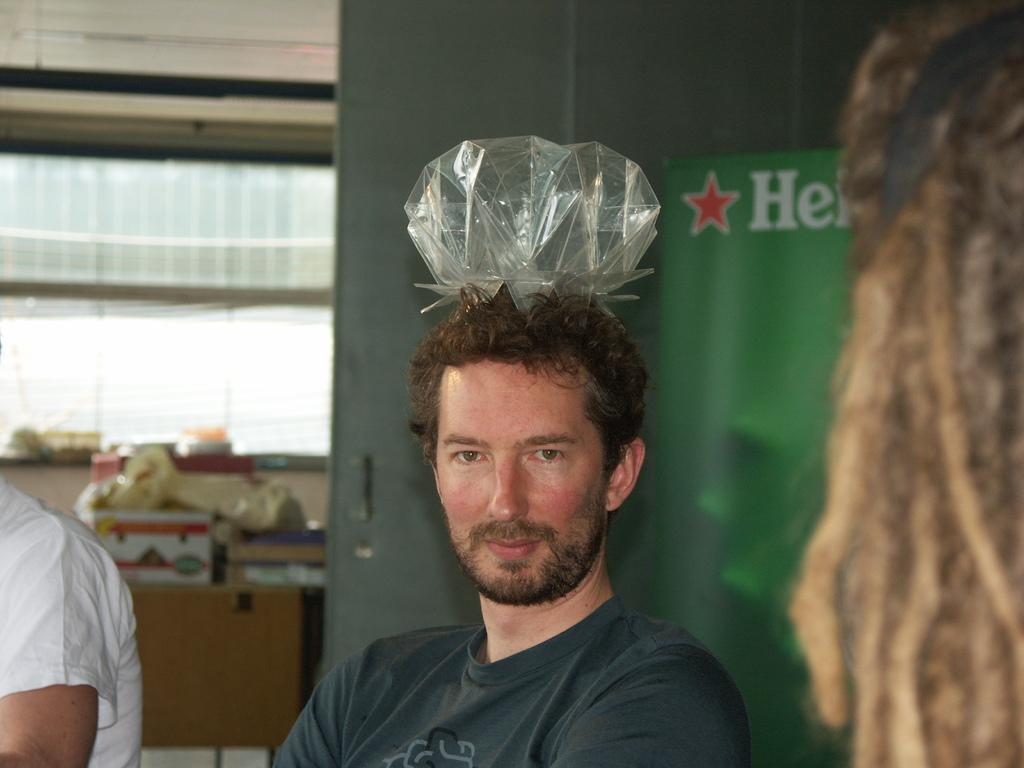How many people are in the image? There are two people in the image. What is on the head of one of the people? One person has an object on their head. What can be seen in the background of the image? There is a poster, boxes, and a wall in the background of the image. What other objects are visible in the background of the image? There are other objects visible in the background of the image. What type of crown is the person wearing in the image? There is no crown present in the image; one person has an object on their head, but it is not specified as a crown. Can you tell me how many times the person swims in the image? There is no swimming activity depicted in the image; it features two people and various objects in the background. 